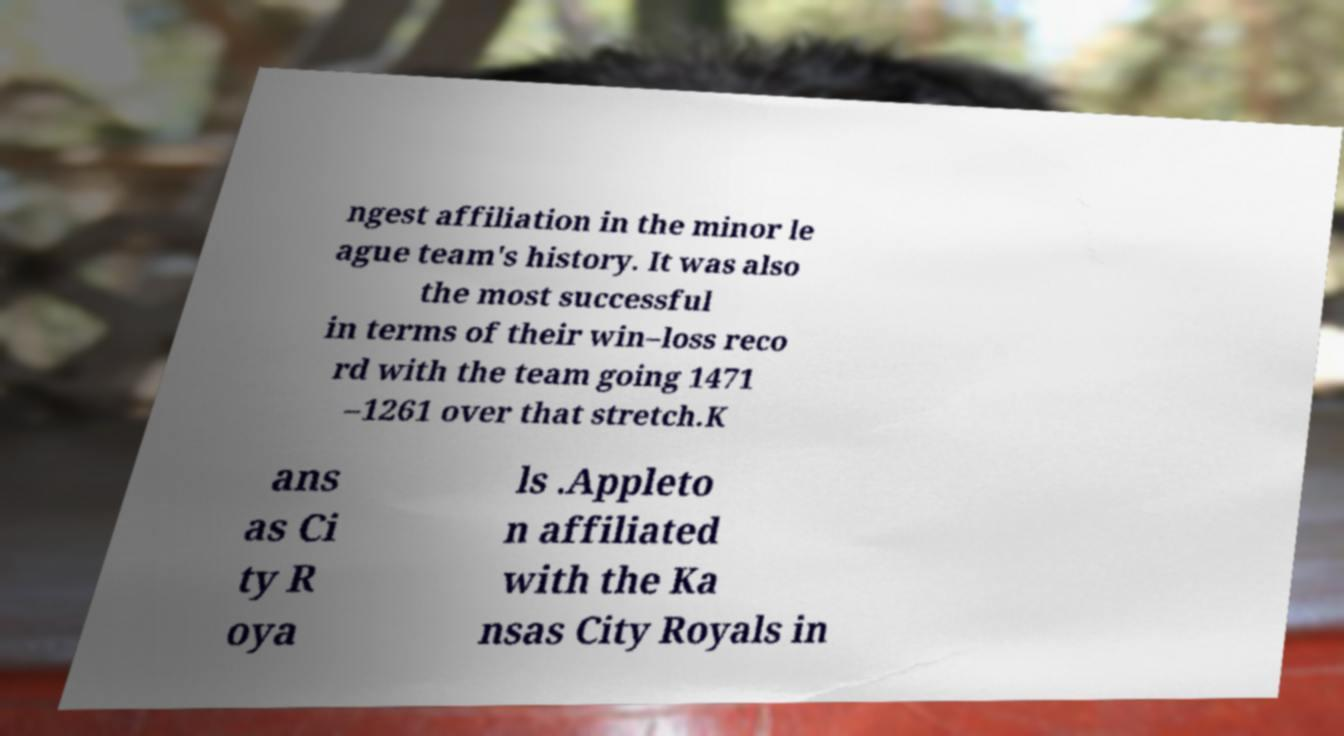I need the written content from this picture converted into text. Can you do that? ngest affiliation in the minor le ague team's history. It was also the most successful in terms of their win–loss reco rd with the team going 1471 –1261 over that stretch.K ans as Ci ty R oya ls .Appleto n affiliated with the Ka nsas City Royals in 